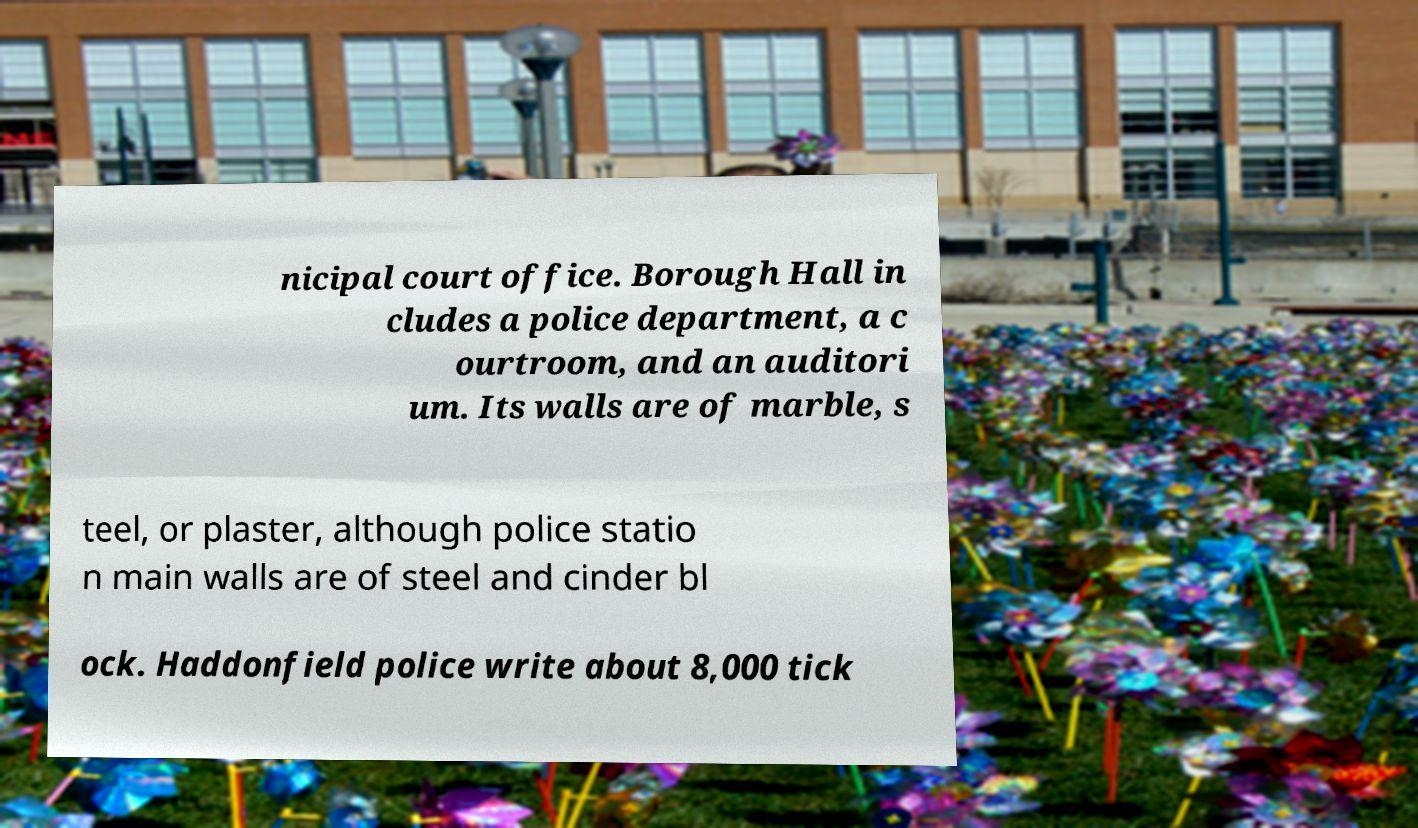For documentation purposes, I need the text within this image transcribed. Could you provide that? nicipal court office. Borough Hall in cludes a police department, a c ourtroom, and an auditori um. Its walls are of marble, s teel, or plaster, although police statio n main walls are of steel and cinder bl ock. Haddonfield police write about 8,000 tick 